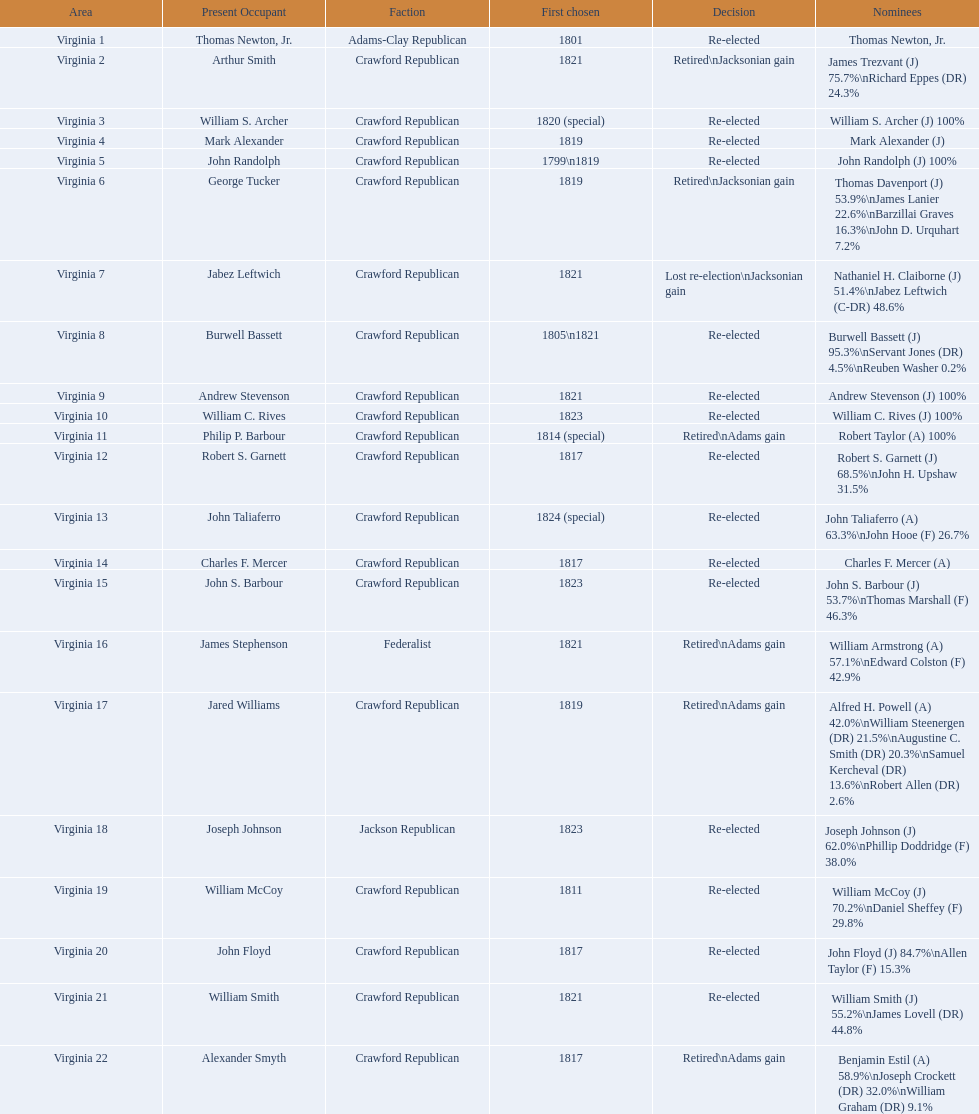How many districts are there in virginia? 22. Could you parse the entire table? {'header': ['Area', 'Present Occupant', 'Faction', 'First chosen', 'Decision', 'Nominees'], 'rows': [['Virginia 1', 'Thomas Newton, Jr.', 'Adams-Clay Republican', '1801', 'Re-elected', 'Thomas Newton, Jr.'], ['Virginia 2', 'Arthur Smith', 'Crawford Republican', '1821', 'Retired\\nJacksonian gain', 'James Trezvant (J) 75.7%\\nRichard Eppes (DR) 24.3%'], ['Virginia 3', 'William S. Archer', 'Crawford Republican', '1820 (special)', 'Re-elected', 'William S. Archer (J) 100%'], ['Virginia 4', 'Mark Alexander', 'Crawford Republican', '1819', 'Re-elected', 'Mark Alexander (J)'], ['Virginia 5', 'John Randolph', 'Crawford Republican', '1799\\n1819', 'Re-elected', 'John Randolph (J) 100%'], ['Virginia 6', 'George Tucker', 'Crawford Republican', '1819', 'Retired\\nJacksonian gain', 'Thomas Davenport (J) 53.9%\\nJames Lanier 22.6%\\nBarzillai Graves 16.3%\\nJohn D. Urquhart 7.2%'], ['Virginia 7', 'Jabez Leftwich', 'Crawford Republican', '1821', 'Lost re-election\\nJacksonian gain', 'Nathaniel H. Claiborne (J) 51.4%\\nJabez Leftwich (C-DR) 48.6%'], ['Virginia 8', 'Burwell Bassett', 'Crawford Republican', '1805\\n1821', 'Re-elected', 'Burwell Bassett (J) 95.3%\\nServant Jones (DR) 4.5%\\nReuben Washer 0.2%'], ['Virginia 9', 'Andrew Stevenson', 'Crawford Republican', '1821', 'Re-elected', 'Andrew Stevenson (J) 100%'], ['Virginia 10', 'William C. Rives', 'Crawford Republican', '1823', 'Re-elected', 'William C. Rives (J) 100%'], ['Virginia 11', 'Philip P. Barbour', 'Crawford Republican', '1814 (special)', 'Retired\\nAdams gain', 'Robert Taylor (A) 100%'], ['Virginia 12', 'Robert S. Garnett', 'Crawford Republican', '1817', 'Re-elected', 'Robert S. Garnett (J) 68.5%\\nJohn H. Upshaw 31.5%'], ['Virginia 13', 'John Taliaferro', 'Crawford Republican', '1824 (special)', 'Re-elected', 'John Taliaferro (A) 63.3%\\nJohn Hooe (F) 26.7%'], ['Virginia 14', 'Charles F. Mercer', 'Crawford Republican', '1817', 'Re-elected', 'Charles F. Mercer (A)'], ['Virginia 15', 'John S. Barbour', 'Crawford Republican', '1823', 'Re-elected', 'John S. Barbour (J) 53.7%\\nThomas Marshall (F) 46.3%'], ['Virginia 16', 'James Stephenson', 'Federalist', '1821', 'Retired\\nAdams gain', 'William Armstrong (A) 57.1%\\nEdward Colston (F) 42.9%'], ['Virginia 17', 'Jared Williams', 'Crawford Republican', '1819', 'Retired\\nAdams gain', 'Alfred H. Powell (A) 42.0%\\nWilliam Steenergen (DR) 21.5%\\nAugustine C. Smith (DR) 20.3%\\nSamuel Kercheval (DR) 13.6%\\nRobert Allen (DR) 2.6%'], ['Virginia 18', 'Joseph Johnson', 'Jackson Republican', '1823', 'Re-elected', 'Joseph Johnson (J) 62.0%\\nPhillip Doddridge (F) 38.0%'], ['Virginia 19', 'William McCoy', 'Crawford Republican', '1811', 'Re-elected', 'William McCoy (J) 70.2%\\nDaniel Sheffey (F) 29.8%'], ['Virginia 20', 'John Floyd', 'Crawford Republican', '1817', 'Re-elected', 'John Floyd (J) 84.7%\\nAllen Taylor (F) 15.3%'], ['Virginia 21', 'William Smith', 'Crawford Republican', '1821', 'Re-elected', 'William Smith (J) 55.2%\\nJames Lovell (DR) 44.8%'], ['Virginia 22', 'Alexander Smyth', 'Crawford Republican', '1817', 'Retired\\nAdams gain', 'Benjamin Estil (A) 58.9%\\nJoseph Crockett (DR) 32.0%\\nWilliam Graham (DR) 9.1%']]} 